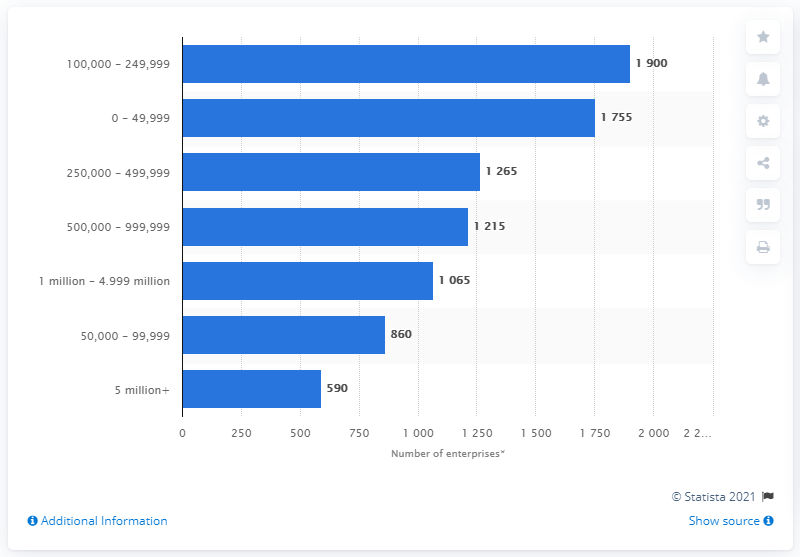Draw attention to some important aspects in this diagram. As of March 2020, there were 590 enterprises in the travel agency, tour operator, and related activities sector that had a turnover of more than £5 million. 